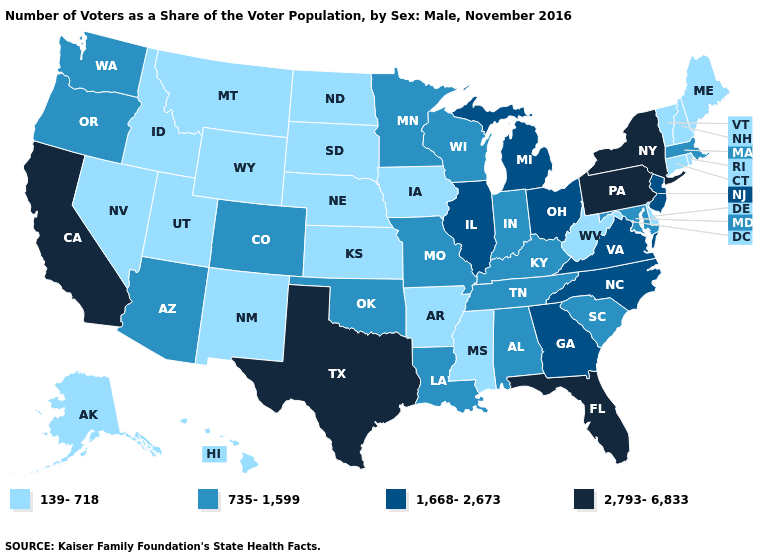What is the value of Maine?
Give a very brief answer. 139-718. Among the states that border Minnesota , does Wisconsin have the lowest value?
Answer briefly. No. Name the states that have a value in the range 1,668-2,673?
Quick response, please. Georgia, Illinois, Michigan, New Jersey, North Carolina, Ohio, Virginia. What is the highest value in states that border Arizona?
Quick response, please. 2,793-6,833. What is the value of Minnesota?
Concise answer only. 735-1,599. What is the value of Mississippi?
Short answer required. 139-718. What is the highest value in states that border Massachusetts?
Give a very brief answer. 2,793-6,833. Which states have the highest value in the USA?
Answer briefly. California, Florida, New York, Pennsylvania, Texas. Among the states that border Colorado , which have the lowest value?
Short answer required. Kansas, Nebraska, New Mexico, Utah, Wyoming. What is the lowest value in the USA?
Keep it brief. 139-718. Which states hav the highest value in the South?
Answer briefly. Florida, Texas. What is the highest value in the West ?
Short answer required. 2,793-6,833. Name the states that have a value in the range 1,668-2,673?
Short answer required. Georgia, Illinois, Michigan, New Jersey, North Carolina, Ohio, Virginia. Name the states that have a value in the range 1,668-2,673?
Write a very short answer. Georgia, Illinois, Michigan, New Jersey, North Carolina, Ohio, Virginia. Name the states that have a value in the range 735-1,599?
Concise answer only. Alabama, Arizona, Colorado, Indiana, Kentucky, Louisiana, Maryland, Massachusetts, Minnesota, Missouri, Oklahoma, Oregon, South Carolina, Tennessee, Washington, Wisconsin. 